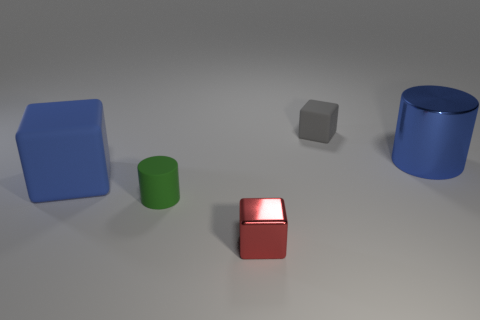Add 2 small green cylinders. How many objects exist? 7 Subtract all blocks. How many objects are left? 2 Subtract all large blue metallic things. Subtract all tiny red metallic balls. How many objects are left? 4 Add 1 gray rubber blocks. How many gray rubber blocks are left? 2 Add 4 small rubber things. How many small rubber things exist? 6 Subtract 0 cyan cylinders. How many objects are left? 5 